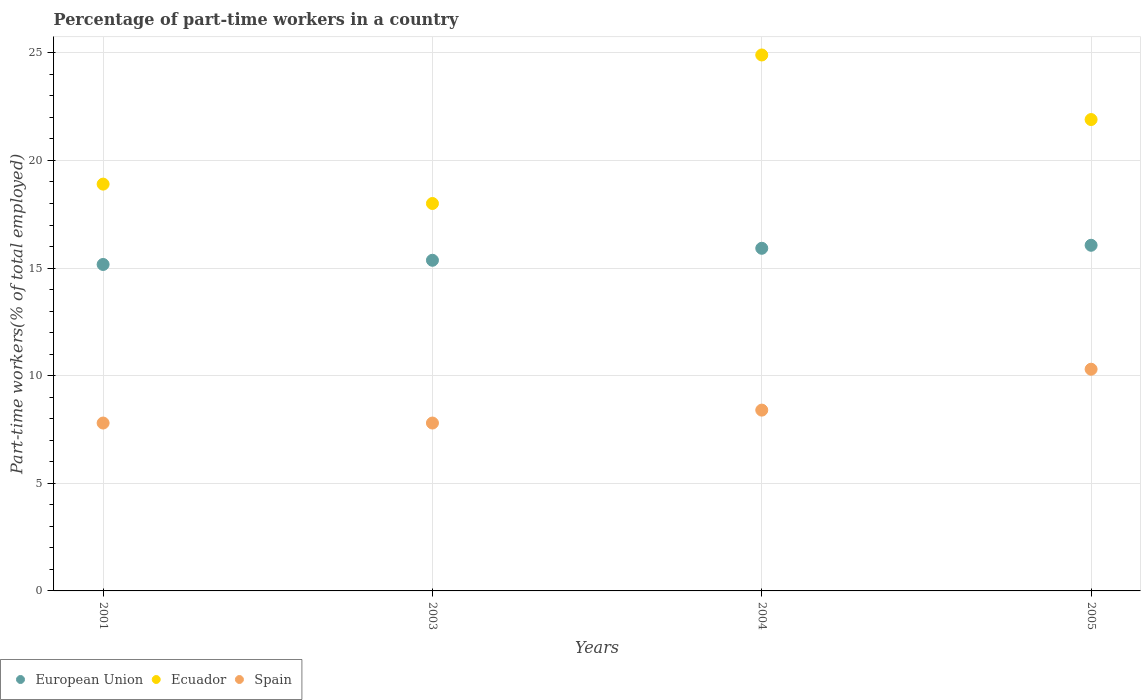Is the number of dotlines equal to the number of legend labels?
Keep it short and to the point. Yes. What is the percentage of part-time workers in Spain in 2001?
Offer a terse response. 7.8. Across all years, what is the maximum percentage of part-time workers in Ecuador?
Your answer should be compact. 24.9. Across all years, what is the minimum percentage of part-time workers in Ecuador?
Provide a short and direct response. 18. In which year was the percentage of part-time workers in Spain maximum?
Provide a short and direct response. 2005. In which year was the percentage of part-time workers in Ecuador minimum?
Your answer should be compact. 2003. What is the total percentage of part-time workers in Ecuador in the graph?
Your answer should be very brief. 83.7. What is the difference between the percentage of part-time workers in Ecuador in 2001 and that in 2005?
Provide a succinct answer. -3. What is the difference between the percentage of part-time workers in Spain in 2004 and the percentage of part-time workers in Ecuador in 2003?
Your response must be concise. -9.6. What is the average percentage of part-time workers in Ecuador per year?
Your answer should be compact. 20.92. In the year 2001, what is the difference between the percentage of part-time workers in European Union and percentage of part-time workers in Ecuador?
Offer a terse response. -3.73. In how many years, is the percentage of part-time workers in European Union greater than 12 %?
Provide a succinct answer. 4. Is the percentage of part-time workers in European Union in 2004 less than that in 2005?
Provide a succinct answer. Yes. Is the difference between the percentage of part-time workers in European Union in 2001 and 2005 greater than the difference between the percentage of part-time workers in Ecuador in 2001 and 2005?
Your answer should be compact. Yes. What is the difference between the highest and the second highest percentage of part-time workers in Spain?
Keep it short and to the point. 1.9. What is the difference between the highest and the lowest percentage of part-time workers in Spain?
Offer a terse response. 2.5. In how many years, is the percentage of part-time workers in Spain greater than the average percentage of part-time workers in Spain taken over all years?
Give a very brief answer. 1. Is the sum of the percentage of part-time workers in Spain in 2003 and 2004 greater than the maximum percentage of part-time workers in Ecuador across all years?
Give a very brief answer. No. Is it the case that in every year, the sum of the percentage of part-time workers in European Union and percentage of part-time workers in Ecuador  is greater than the percentage of part-time workers in Spain?
Your response must be concise. Yes. Is the percentage of part-time workers in European Union strictly less than the percentage of part-time workers in Ecuador over the years?
Your response must be concise. Yes. How many dotlines are there?
Offer a terse response. 3. How many years are there in the graph?
Provide a short and direct response. 4. Does the graph contain any zero values?
Offer a terse response. No. Does the graph contain grids?
Offer a very short reply. Yes. How many legend labels are there?
Offer a very short reply. 3. How are the legend labels stacked?
Give a very brief answer. Horizontal. What is the title of the graph?
Keep it short and to the point. Percentage of part-time workers in a country. Does "Small states" appear as one of the legend labels in the graph?
Offer a very short reply. No. What is the label or title of the X-axis?
Provide a succinct answer. Years. What is the label or title of the Y-axis?
Offer a very short reply. Part-time workers(% of total employed). What is the Part-time workers(% of total employed) of European Union in 2001?
Give a very brief answer. 15.17. What is the Part-time workers(% of total employed) in Ecuador in 2001?
Give a very brief answer. 18.9. What is the Part-time workers(% of total employed) of Spain in 2001?
Offer a very short reply. 7.8. What is the Part-time workers(% of total employed) in European Union in 2003?
Give a very brief answer. 15.36. What is the Part-time workers(% of total employed) of Ecuador in 2003?
Make the answer very short. 18. What is the Part-time workers(% of total employed) in Spain in 2003?
Your answer should be compact. 7.8. What is the Part-time workers(% of total employed) of European Union in 2004?
Provide a succinct answer. 15.92. What is the Part-time workers(% of total employed) of Ecuador in 2004?
Give a very brief answer. 24.9. What is the Part-time workers(% of total employed) of Spain in 2004?
Make the answer very short. 8.4. What is the Part-time workers(% of total employed) in European Union in 2005?
Provide a short and direct response. 16.06. What is the Part-time workers(% of total employed) in Ecuador in 2005?
Offer a terse response. 21.9. What is the Part-time workers(% of total employed) in Spain in 2005?
Offer a terse response. 10.3. Across all years, what is the maximum Part-time workers(% of total employed) of European Union?
Keep it short and to the point. 16.06. Across all years, what is the maximum Part-time workers(% of total employed) of Ecuador?
Your answer should be very brief. 24.9. Across all years, what is the maximum Part-time workers(% of total employed) of Spain?
Give a very brief answer. 10.3. Across all years, what is the minimum Part-time workers(% of total employed) of European Union?
Your answer should be compact. 15.17. Across all years, what is the minimum Part-time workers(% of total employed) of Ecuador?
Your response must be concise. 18. Across all years, what is the minimum Part-time workers(% of total employed) of Spain?
Provide a short and direct response. 7.8. What is the total Part-time workers(% of total employed) of European Union in the graph?
Ensure brevity in your answer.  62.51. What is the total Part-time workers(% of total employed) of Ecuador in the graph?
Make the answer very short. 83.7. What is the total Part-time workers(% of total employed) of Spain in the graph?
Provide a short and direct response. 34.3. What is the difference between the Part-time workers(% of total employed) of European Union in 2001 and that in 2003?
Provide a succinct answer. -0.19. What is the difference between the Part-time workers(% of total employed) of Spain in 2001 and that in 2003?
Give a very brief answer. 0. What is the difference between the Part-time workers(% of total employed) of European Union in 2001 and that in 2004?
Provide a short and direct response. -0.75. What is the difference between the Part-time workers(% of total employed) in Ecuador in 2001 and that in 2004?
Give a very brief answer. -6. What is the difference between the Part-time workers(% of total employed) of European Union in 2001 and that in 2005?
Make the answer very short. -0.89. What is the difference between the Part-time workers(% of total employed) of Ecuador in 2001 and that in 2005?
Give a very brief answer. -3. What is the difference between the Part-time workers(% of total employed) of Spain in 2001 and that in 2005?
Give a very brief answer. -2.5. What is the difference between the Part-time workers(% of total employed) in European Union in 2003 and that in 2004?
Provide a succinct answer. -0.56. What is the difference between the Part-time workers(% of total employed) of Spain in 2003 and that in 2004?
Offer a very short reply. -0.6. What is the difference between the Part-time workers(% of total employed) in European Union in 2003 and that in 2005?
Make the answer very short. -0.7. What is the difference between the Part-time workers(% of total employed) of Ecuador in 2003 and that in 2005?
Provide a short and direct response. -3.9. What is the difference between the Part-time workers(% of total employed) in European Union in 2004 and that in 2005?
Offer a very short reply. -0.14. What is the difference between the Part-time workers(% of total employed) in Ecuador in 2004 and that in 2005?
Your answer should be very brief. 3. What is the difference between the Part-time workers(% of total employed) of European Union in 2001 and the Part-time workers(% of total employed) of Ecuador in 2003?
Offer a very short reply. -2.83. What is the difference between the Part-time workers(% of total employed) in European Union in 2001 and the Part-time workers(% of total employed) in Spain in 2003?
Ensure brevity in your answer.  7.37. What is the difference between the Part-time workers(% of total employed) in European Union in 2001 and the Part-time workers(% of total employed) in Ecuador in 2004?
Offer a terse response. -9.73. What is the difference between the Part-time workers(% of total employed) of European Union in 2001 and the Part-time workers(% of total employed) of Spain in 2004?
Ensure brevity in your answer.  6.77. What is the difference between the Part-time workers(% of total employed) of European Union in 2001 and the Part-time workers(% of total employed) of Ecuador in 2005?
Keep it short and to the point. -6.73. What is the difference between the Part-time workers(% of total employed) of European Union in 2001 and the Part-time workers(% of total employed) of Spain in 2005?
Provide a succinct answer. 4.87. What is the difference between the Part-time workers(% of total employed) in European Union in 2003 and the Part-time workers(% of total employed) in Ecuador in 2004?
Your answer should be very brief. -9.54. What is the difference between the Part-time workers(% of total employed) of European Union in 2003 and the Part-time workers(% of total employed) of Spain in 2004?
Offer a terse response. 6.96. What is the difference between the Part-time workers(% of total employed) of Ecuador in 2003 and the Part-time workers(% of total employed) of Spain in 2004?
Provide a succinct answer. 9.6. What is the difference between the Part-time workers(% of total employed) of European Union in 2003 and the Part-time workers(% of total employed) of Ecuador in 2005?
Ensure brevity in your answer.  -6.54. What is the difference between the Part-time workers(% of total employed) in European Union in 2003 and the Part-time workers(% of total employed) in Spain in 2005?
Make the answer very short. 5.06. What is the difference between the Part-time workers(% of total employed) of Ecuador in 2003 and the Part-time workers(% of total employed) of Spain in 2005?
Provide a succinct answer. 7.7. What is the difference between the Part-time workers(% of total employed) in European Union in 2004 and the Part-time workers(% of total employed) in Ecuador in 2005?
Make the answer very short. -5.98. What is the difference between the Part-time workers(% of total employed) of European Union in 2004 and the Part-time workers(% of total employed) of Spain in 2005?
Provide a succinct answer. 5.62. What is the difference between the Part-time workers(% of total employed) in Ecuador in 2004 and the Part-time workers(% of total employed) in Spain in 2005?
Keep it short and to the point. 14.6. What is the average Part-time workers(% of total employed) of European Union per year?
Provide a succinct answer. 15.63. What is the average Part-time workers(% of total employed) of Ecuador per year?
Give a very brief answer. 20.93. What is the average Part-time workers(% of total employed) in Spain per year?
Your response must be concise. 8.57. In the year 2001, what is the difference between the Part-time workers(% of total employed) of European Union and Part-time workers(% of total employed) of Ecuador?
Ensure brevity in your answer.  -3.73. In the year 2001, what is the difference between the Part-time workers(% of total employed) of European Union and Part-time workers(% of total employed) of Spain?
Provide a short and direct response. 7.37. In the year 2001, what is the difference between the Part-time workers(% of total employed) in Ecuador and Part-time workers(% of total employed) in Spain?
Your response must be concise. 11.1. In the year 2003, what is the difference between the Part-time workers(% of total employed) of European Union and Part-time workers(% of total employed) of Ecuador?
Ensure brevity in your answer.  -2.64. In the year 2003, what is the difference between the Part-time workers(% of total employed) in European Union and Part-time workers(% of total employed) in Spain?
Offer a very short reply. 7.56. In the year 2003, what is the difference between the Part-time workers(% of total employed) in Ecuador and Part-time workers(% of total employed) in Spain?
Your response must be concise. 10.2. In the year 2004, what is the difference between the Part-time workers(% of total employed) in European Union and Part-time workers(% of total employed) in Ecuador?
Give a very brief answer. -8.98. In the year 2004, what is the difference between the Part-time workers(% of total employed) in European Union and Part-time workers(% of total employed) in Spain?
Make the answer very short. 7.52. In the year 2005, what is the difference between the Part-time workers(% of total employed) of European Union and Part-time workers(% of total employed) of Ecuador?
Your answer should be compact. -5.84. In the year 2005, what is the difference between the Part-time workers(% of total employed) of European Union and Part-time workers(% of total employed) of Spain?
Give a very brief answer. 5.76. In the year 2005, what is the difference between the Part-time workers(% of total employed) of Ecuador and Part-time workers(% of total employed) of Spain?
Give a very brief answer. 11.6. What is the ratio of the Part-time workers(% of total employed) in European Union in 2001 to that in 2003?
Your answer should be very brief. 0.99. What is the ratio of the Part-time workers(% of total employed) in Ecuador in 2001 to that in 2003?
Keep it short and to the point. 1.05. What is the ratio of the Part-time workers(% of total employed) in European Union in 2001 to that in 2004?
Keep it short and to the point. 0.95. What is the ratio of the Part-time workers(% of total employed) in Ecuador in 2001 to that in 2004?
Your answer should be very brief. 0.76. What is the ratio of the Part-time workers(% of total employed) in European Union in 2001 to that in 2005?
Your answer should be very brief. 0.94. What is the ratio of the Part-time workers(% of total employed) of Ecuador in 2001 to that in 2005?
Offer a terse response. 0.86. What is the ratio of the Part-time workers(% of total employed) of Spain in 2001 to that in 2005?
Provide a short and direct response. 0.76. What is the ratio of the Part-time workers(% of total employed) of Ecuador in 2003 to that in 2004?
Your answer should be very brief. 0.72. What is the ratio of the Part-time workers(% of total employed) in Spain in 2003 to that in 2004?
Ensure brevity in your answer.  0.93. What is the ratio of the Part-time workers(% of total employed) of European Union in 2003 to that in 2005?
Provide a succinct answer. 0.96. What is the ratio of the Part-time workers(% of total employed) in Ecuador in 2003 to that in 2005?
Your answer should be very brief. 0.82. What is the ratio of the Part-time workers(% of total employed) in Spain in 2003 to that in 2005?
Offer a very short reply. 0.76. What is the ratio of the Part-time workers(% of total employed) in European Union in 2004 to that in 2005?
Your answer should be compact. 0.99. What is the ratio of the Part-time workers(% of total employed) of Ecuador in 2004 to that in 2005?
Make the answer very short. 1.14. What is the ratio of the Part-time workers(% of total employed) of Spain in 2004 to that in 2005?
Offer a very short reply. 0.82. What is the difference between the highest and the second highest Part-time workers(% of total employed) in European Union?
Give a very brief answer. 0.14. What is the difference between the highest and the lowest Part-time workers(% of total employed) of European Union?
Your answer should be compact. 0.89. 